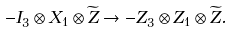Convert formula to latex. <formula><loc_0><loc_0><loc_500><loc_500>- I _ { 3 } \otimes X _ { 1 } \otimes \widetilde { Z } \rightarrow - Z _ { 3 } \otimes Z _ { 1 } \otimes \widetilde { Z } .</formula> 